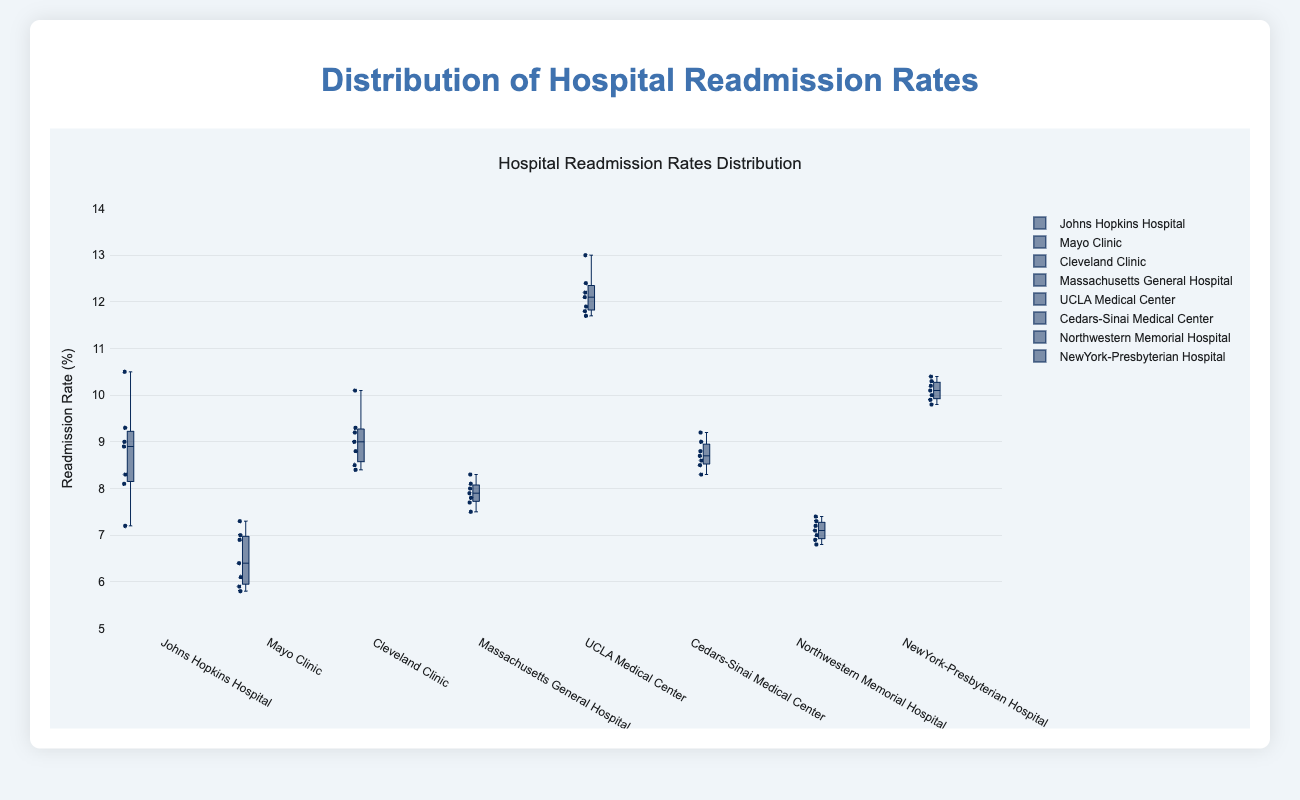What is the title of the plot? The title is located at the top of the plot and usually provides a summary of what the plot represents. In this case, it is "Distribution of Hospital Readmission Rates".
Answer: Distribution of Hospital Readmission Rates What is the readmission rate range displayed on the y-axis? The y-axis shows the range of readmission rates. By examining the y-axis labels, we observe that it spans from 5% to 14%.
Answer: 5% to 14% Which hospital has the highest median readmission rate? The median readmission rate for each hospital can be identified by the central line in each box. By comparing these medians, UCLA Medical Center has the highest median readmission rate.
Answer: UCLA Medical Center Which hospital has the lowest variability in readmission rates? Variability can be assessed by the length of the interquartile range (IQR) and the whiskers. The Mayo Clinic's boxplot, with a smaller IQR and shorter whiskers, indicates the lowest variability.
Answer: Mayo Clinic What are the outliers in the readmission rates of Johns Hopkins Hospital? Outliers are identified by individual points outside the whiskers. For Johns Hopkins Hospital, we observe one outlier at approximately 10.5%.
Answer: 10.5% Compare the interquartile range (IQR) between Cleveland Clinic and Northwestern Memorial Hospital. Which one is larger? The IQR is represented by the height of the box. Cleveland Clinic's IQR appears larger compared to Northwestern Memorial Hospital's smaller IQR box.
Answer: Cleveland Clinic How does the upper quartile of Cedars-Sinai Medical Center compare to the upper quartile of Massachusetts General Hospital? The upper quartile, shown by the top edge of the box, for Cedars-Sinai Medical Center is slightly less than that of Massachusetts General Hospital. This tells us Massachusetts General Hospital has a higher upper quartile readmission rate.
Answer: Massachusetts General Hospital is higher What is the range of readmission rates for NewYork-Presbyterian Hospital? The range can be determined by the distance between the lowest and highest whisker lines. For NewYork-Presbyterian Hospital, the range is from approximately 9.8% to 10.4%.
Answer: 9.8% to 10.4% Which hospital has the highest maximum readmission rate? The maximum readmission rate for each hospital is indicated by the top whisker line or any marked outlier point. UCLA Medical Center has the highest maximum readmission rate at around 13%.
Answer: UCLA Medical Center Compare the median readmission rates of Johns Hopkins Hospital and Cleveland Clinic. The median readmission rate is the line inside the box. Johns Hopkins Hospital has a median slightly above 8.5%, whereas Cleveland Clinic's median is also around 9%, indicating Cleveland Clinic has a slightly higher median readmission rate.
Answer: Cleveland Clinic is slightly higher 